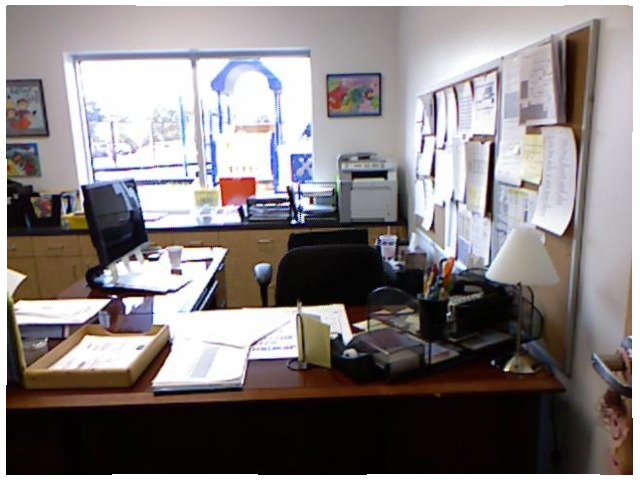<image>
Is the papers on the desk? No. The papers is not positioned on the desk. They may be near each other, but the papers is not supported by or resting on top of the desk. Is the coffee behind the keyboard? Yes. From this viewpoint, the coffee is positioned behind the keyboard, with the keyboard partially or fully occluding the coffee. Is the picture to the right of the door? Yes. From this viewpoint, the picture is positioned to the right side relative to the door. Is there a computer monitor next to the window? No. The computer monitor is not positioned next to the window. They are located in different areas of the scene. 